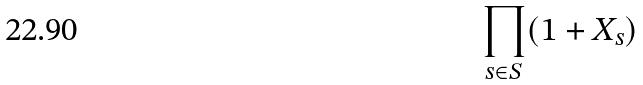Convert formula to latex. <formula><loc_0><loc_0><loc_500><loc_500>\prod _ { s \in S } ( 1 + X _ { s } )</formula> 